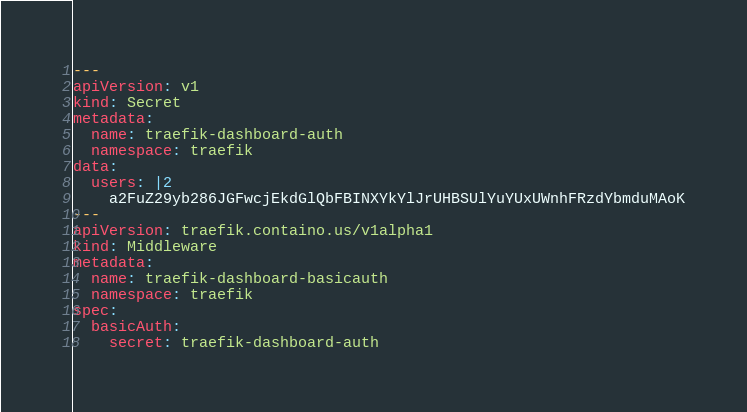<code> <loc_0><loc_0><loc_500><loc_500><_YAML_>---
apiVersion: v1
kind: Secret
metadata:
  name: traefik-dashboard-auth
  namespace: traefik
data:
  users: |2
    a2FuZ29yb286JGFwcjEkdGlQbFBINXYkYlJrUHBSUlYuYUxUWnhFRzdYbmduMAoK
---
apiVersion: traefik.containo.us/v1alpha1
kind: Middleware
metadata:
  name: traefik-dashboard-basicauth
  namespace: traefik
spec:
  basicAuth:
    secret: traefik-dashboard-auth
</code> 